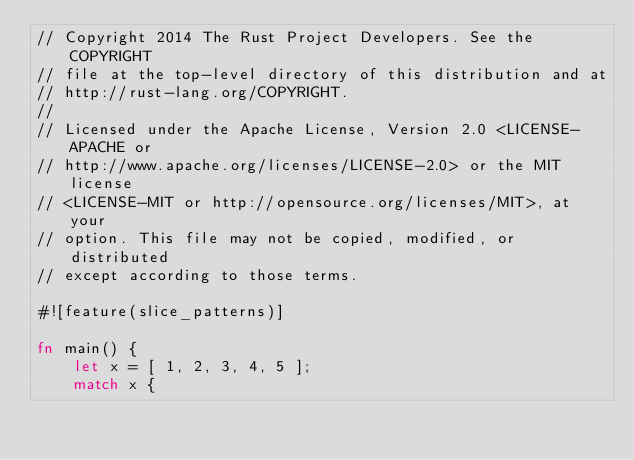<code> <loc_0><loc_0><loc_500><loc_500><_Rust_>// Copyright 2014 The Rust Project Developers. See the COPYRIGHT
// file at the top-level directory of this distribution and at
// http://rust-lang.org/COPYRIGHT.
//
// Licensed under the Apache License, Version 2.0 <LICENSE-APACHE or
// http://www.apache.org/licenses/LICENSE-2.0> or the MIT license
// <LICENSE-MIT or http://opensource.org/licenses/MIT>, at your
// option. This file may not be copied, modified, or distributed
// except according to those terms.

#![feature(slice_patterns)]

fn main() {
    let x = [ 1, 2, 3, 4, 5 ];
    match x {</code> 